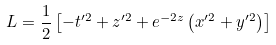Convert formula to latex. <formula><loc_0><loc_0><loc_500><loc_500>L = { \frac { 1 } { 2 } } \left [ - t ^ { \prime 2 } + z ^ { \prime 2 } + e ^ { - 2 z } \left ( x ^ { \prime 2 } + y ^ { \prime 2 } \right ) \right ]</formula> 